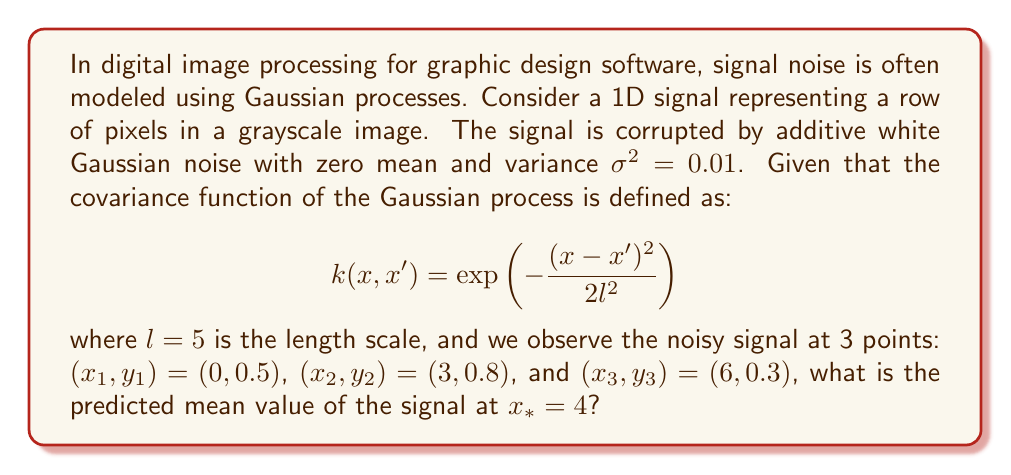Could you help me with this problem? To solve this problem, we'll use Gaussian process regression. The steps are as follows:

1) First, we need to construct the covariance matrix K for the observed points:

   $$K_{ij} = k(x_i, x_j) + \sigma^2\delta_{ij}$$

   where $\delta_{ij}$ is the Kronecker delta.

2) Calculate the elements of K:
   
   $$K_{11} = k(0,0) + 0.01 = 1 + 0.01 = 1.01$$
   $$K_{22} = K_{33} = 1.01$$
   $$K_{12} = K_{21} = \exp(-\frac{(0-3)^2}{2\cdot5^2}) = \exp(-0.18) \approx 0.8353$$
   $$K_{13} = K_{31} = \exp(-\frac{(0-6)^2}{2\cdot5^2}) = \exp(-0.72) \approx 0.4868$$
   $$K_{23} = K_{32} = \exp(-\frac{(3-6)^2}{2\cdot5^2}) = \exp(-0.18) \approx 0.8353$$

3) The covariance matrix K is:

   $$K = \begin{bmatrix}
   1.01 & 0.8353 & 0.4868 \\
   0.8353 & 1.01 & 0.8353 \\
   0.4868 & 0.8353 & 1.01
   \end{bmatrix}$$

4) Calculate the covariance vector k* between the test point x* = 4 and the observed points:

   $$k_* = [k(4,0), k(4,3), k(4,6)]$$
   $$k_* = [\exp(-\frac{16}{50}), \exp(-\frac{1}{50}), \exp(-\frac{4}{50})]$$
   $$k_* \approx [0.7261, 0.9802, 0.9231]$$

5) The predicted mean at x* is given by:

   $$\mu_* = k_*^T K^{-1} y$$

   where y is the vector of observed values [0.5, 0.8, 0.3]

6) Calculate K^(-1)y:

   $$K^{-1}y \approx [0.6847, 0.7910, 0.0154]$$

7) Finally, calculate the predicted mean:

   $$\mu_* = 0.7261 * 0.6847 + 0.9802 * 0.7910 + 0.9231 * 0.0154$$
   $$\mu_* \approx 0.7747$$
Answer: 0.7747 